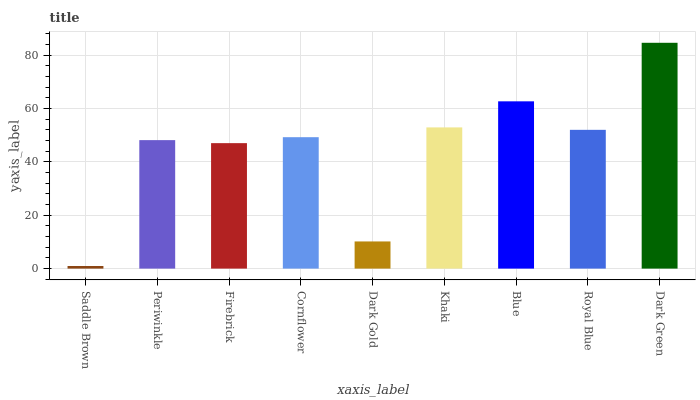Is Saddle Brown the minimum?
Answer yes or no. Yes. Is Dark Green the maximum?
Answer yes or no. Yes. Is Periwinkle the minimum?
Answer yes or no. No. Is Periwinkle the maximum?
Answer yes or no. No. Is Periwinkle greater than Saddle Brown?
Answer yes or no. Yes. Is Saddle Brown less than Periwinkle?
Answer yes or no. Yes. Is Saddle Brown greater than Periwinkle?
Answer yes or no. No. Is Periwinkle less than Saddle Brown?
Answer yes or no. No. Is Cornflower the high median?
Answer yes or no. Yes. Is Cornflower the low median?
Answer yes or no. Yes. Is Royal Blue the high median?
Answer yes or no. No. Is Dark Gold the low median?
Answer yes or no. No. 